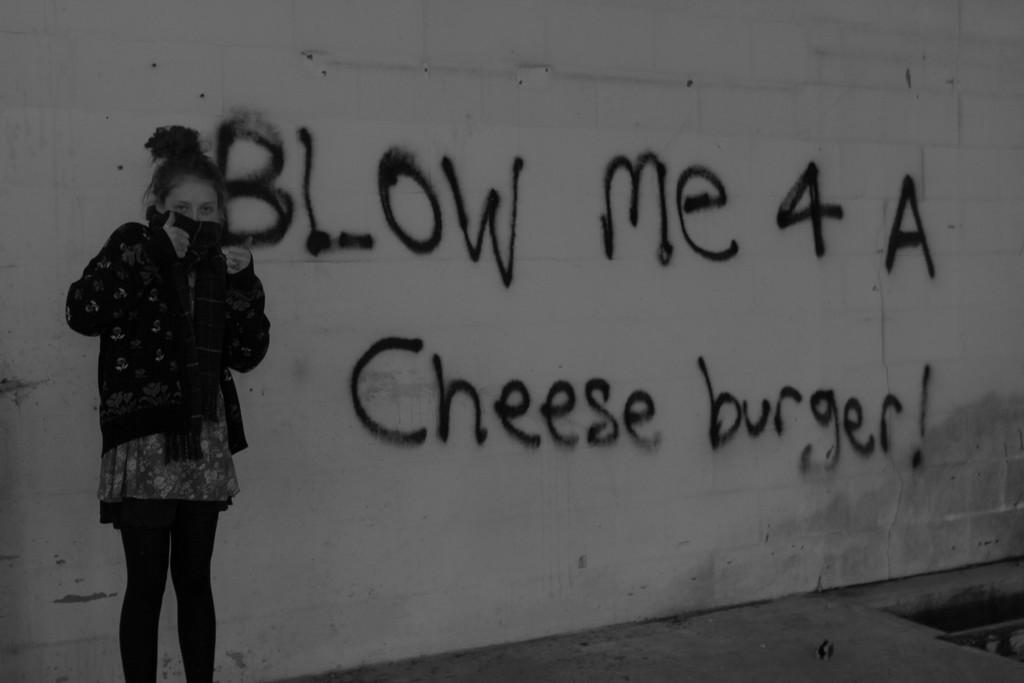What is the main subject of the image? There is a woman standing in the image. Where is the woman standing? The woman is standing on the floor. What can be seen in the background of the image? There is a wall with text in the background of the image. What type of stocking is the woman wearing in the image? There is no information about the woman's clothing, including stockings, in the image. 